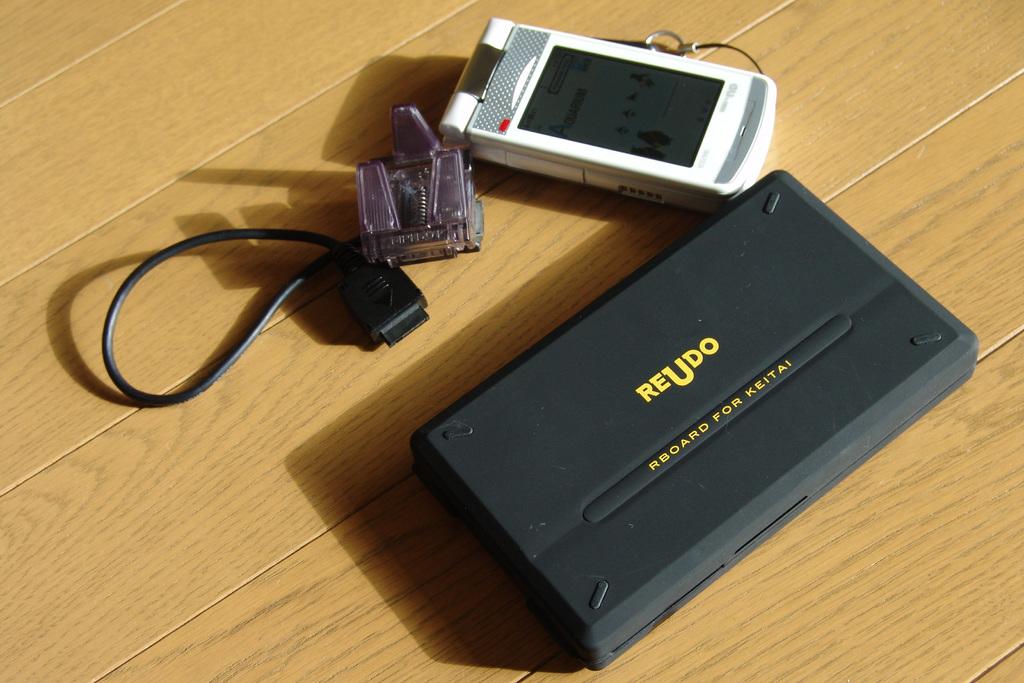What's the brand name of the box?
Provide a short and direct response. Reudo. 